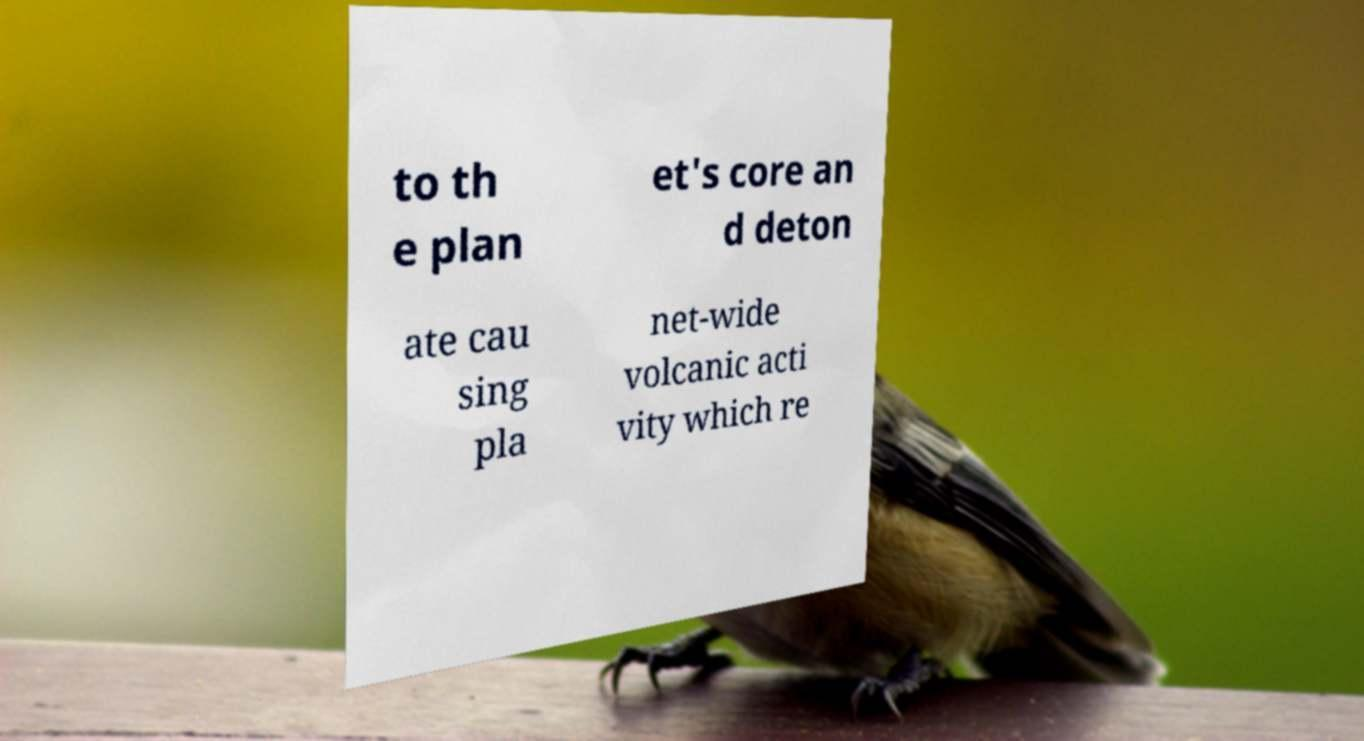What messages or text are displayed in this image? I need them in a readable, typed format. to th e plan et's core an d deton ate cau sing pla net-wide volcanic acti vity which re 